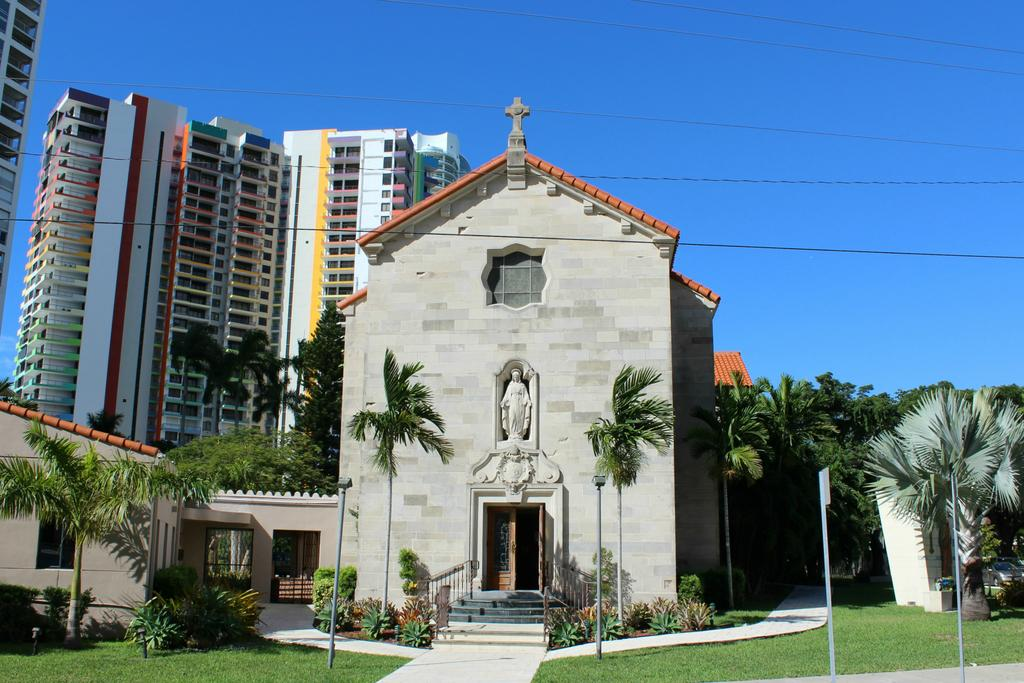What type of structures can be seen in the image? There are buildings in the image. What type of vegetation is present in the image? There are trees, plants, and grass in the image. What architectural features can be seen in the image? There are windows and a sculpture in the image. What other objects can be seen in the image? There are poles, wires, and a sculpture in the image. What is visible in the background of the image? The sky is visible in the background of the image. Can you see a boat in the image? No, there is no boat present in the image. How many hands are visible in the image? There are no hands visible in the image. 